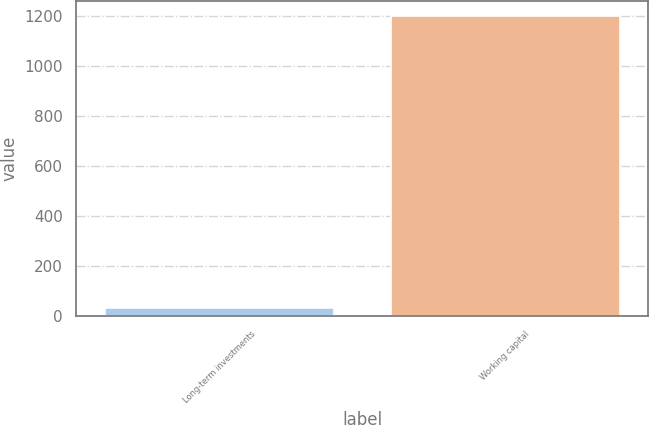Convert chart to OTSL. <chart><loc_0><loc_0><loc_500><loc_500><bar_chart><fcel>Long-term investments<fcel>Working capital<nl><fcel>31<fcel>1200<nl></chart> 